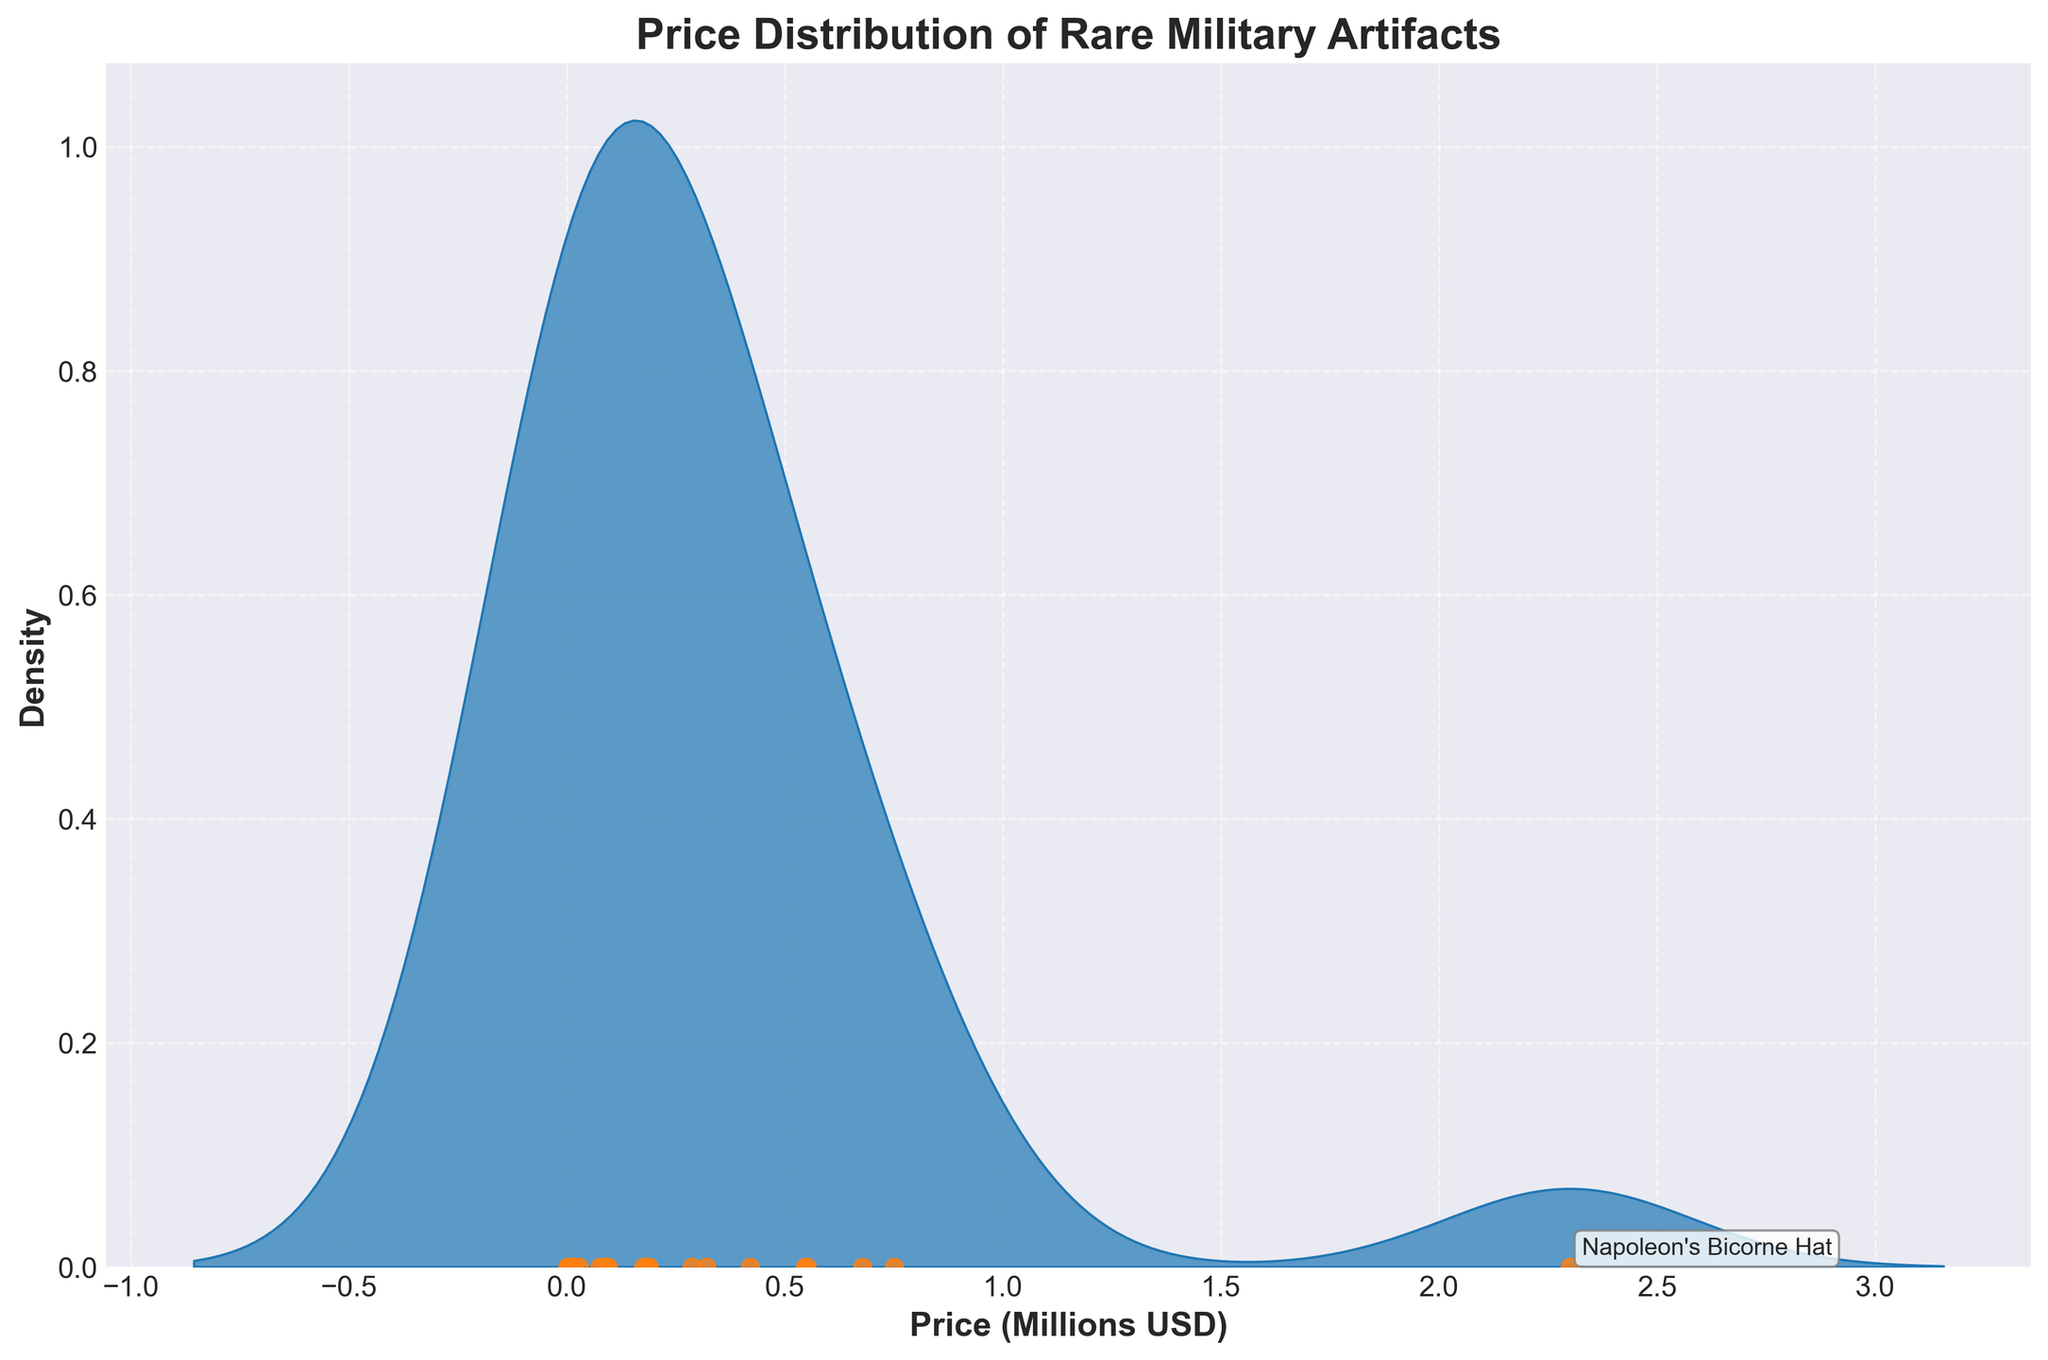What is the title of the plot? The title of the plot is displayed prominently at the top of the figure, indicating the theme of the data visualization.
Answer: Price Distribution of Rare Military Artifacts How is the data for each artifact visually represented on the plot? The plot uses scatter points along the horizontal axis to represent individual artifact prices, with prices in millions.
Answer: Scatter points What does the horizontal axis represent in the plot? The horizontal axis is labeled "Price (Millions USD)" and displays the price of each artifact in millions of USD.
Answer: Price in millions USD How many artifacts are priced over a million dollars? By looking at the scatter points and text annotations, we can count the number of points positioned above the 1 million mark.
Answer: 3 artifacts Which artifact sold for approximately the highest price, and how much was it? The text annotation on the far right of the plot indicates the artifact name and its corresponding price in millions of USD.
Answer: Napoleon's Bicorne Hat, $2.3M What information does the density curve provide? The density curve shows the distribution of the prices of the artifacts. The areas where the curve is higher indicate more frequent price ranges.
Answer: Distribution frequency What price range seems to have the highest density of artifact prices? Observing the density curve, we can identify the price range where the curve peaks the highest.
Answer: Around 0.1 to 0.5 million USD Which artifact with a price below 1 million USD is mentioned with a text annotation? Annotations are provided for notable artifacts; by checking those below the 1 million mark, the name can be identified.
Answer: Napoleon's Campaign Chair What is the range of prices for the artifacts in the dataset? The scatter points along the horizontal axis show the lowest and highest prices when converted from millions back to USD.
Answer: $1,800 to $2,300,000 Which artifact is marked with the highest price under 1 million USD? Look for the text annotation closest to, but under, 1 million on the price axis.
Answer: Medieval Knight's Armor, $750,000 